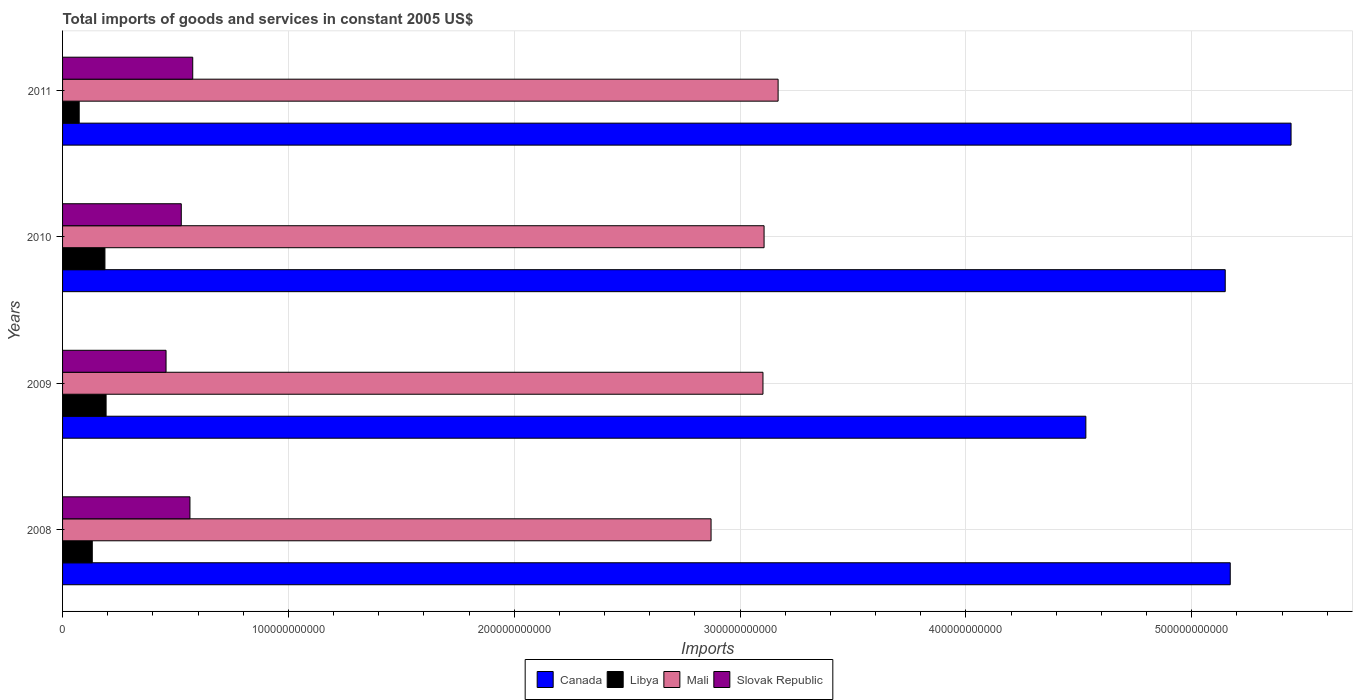Are the number of bars on each tick of the Y-axis equal?
Keep it short and to the point. Yes. How many bars are there on the 4th tick from the top?
Offer a very short reply. 4. What is the total imports of goods and services in Libya in 2010?
Provide a short and direct response. 1.88e+1. Across all years, what is the maximum total imports of goods and services in Slovak Republic?
Your answer should be compact. 5.76e+1. Across all years, what is the minimum total imports of goods and services in Canada?
Provide a short and direct response. 4.53e+11. In which year was the total imports of goods and services in Libya maximum?
Offer a very short reply. 2009. What is the total total imports of goods and services in Slovak Republic in the graph?
Provide a short and direct response. 2.12e+11. What is the difference between the total imports of goods and services in Slovak Republic in 2008 and that in 2009?
Offer a very short reply. 1.06e+1. What is the difference between the total imports of goods and services in Mali in 2009 and the total imports of goods and services in Slovak Republic in 2008?
Keep it short and to the point. 2.54e+11. What is the average total imports of goods and services in Mali per year?
Offer a very short reply. 3.06e+11. In the year 2011, what is the difference between the total imports of goods and services in Mali and total imports of goods and services in Slovak Republic?
Provide a short and direct response. 2.59e+11. In how many years, is the total imports of goods and services in Canada greater than 100000000000 US$?
Your answer should be compact. 4. What is the ratio of the total imports of goods and services in Slovak Republic in 2010 to that in 2011?
Give a very brief answer. 0.91. Is the total imports of goods and services in Mali in 2010 less than that in 2011?
Provide a succinct answer. Yes. What is the difference between the highest and the second highest total imports of goods and services in Canada?
Keep it short and to the point. 2.69e+1. What is the difference between the highest and the lowest total imports of goods and services in Libya?
Ensure brevity in your answer.  1.19e+1. In how many years, is the total imports of goods and services in Slovak Republic greater than the average total imports of goods and services in Slovak Republic taken over all years?
Offer a very short reply. 2. Is the sum of the total imports of goods and services in Libya in 2009 and 2010 greater than the maximum total imports of goods and services in Mali across all years?
Your answer should be compact. No. What does the 1st bar from the top in 2009 represents?
Provide a short and direct response. Slovak Republic. How many bars are there?
Give a very brief answer. 16. Are all the bars in the graph horizontal?
Offer a very short reply. Yes. How many years are there in the graph?
Keep it short and to the point. 4. What is the difference between two consecutive major ticks on the X-axis?
Your answer should be very brief. 1.00e+11. Are the values on the major ticks of X-axis written in scientific E-notation?
Your answer should be compact. No. How are the legend labels stacked?
Give a very brief answer. Horizontal. What is the title of the graph?
Ensure brevity in your answer.  Total imports of goods and services in constant 2005 US$. What is the label or title of the X-axis?
Your answer should be very brief. Imports. What is the label or title of the Y-axis?
Ensure brevity in your answer.  Years. What is the Imports in Canada in 2008?
Your answer should be compact. 5.17e+11. What is the Imports of Libya in 2008?
Offer a terse response. 1.32e+1. What is the Imports of Mali in 2008?
Your answer should be compact. 2.87e+11. What is the Imports of Slovak Republic in 2008?
Ensure brevity in your answer.  5.64e+1. What is the Imports of Canada in 2009?
Offer a very short reply. 4.53e+11. What is the Imports in Libya in 2009?
Your answer should be compact. 1.93e+1. What is the Imports of Mali in 2009?
Your answer should be very brief. 3.10e+11. What is the Imports of Slovak Republic in 2009?
Your response must be concise. 4.58e+1. What is the Imports of Canada in 2010?
Give a very brief answer. 5.15e+11. What is the Imports in Libya in 2010?
Your answer should be compact. 1.88e+1. What is the Imports of Mali in 2010?
Ensure brevity in your answer.  3.11e+11. What is the Imports of Slovak Republic in 2010?
Your answer should be very brief. 5.26e+1. What is the Imports in Canada in 2011?
Provide a succinct answer. 5.44e+11. What is the Imports of Libya in 2011?
Your answer should be very brief. 7.36e+09. What is the Imports in Mali in 2011?
Offer a terse response. 3.17e+11. What is the Imports in Slovak Republic in 2011?
Your response must be concise. 5.76e+1. Across all years, what is the maximum Imports in Canada?
Provide a short and direct response. 5.44e+11. Across all years, what is the maximum Imports in Libya?
Give a very brief answer. 1.93e+1. Across all years, what is the maximum Imports of Mali?
Give a very brief answer. 3.17e+11. Across all years, what is the maximum Imports in Slovak Republic?
Make the answer very short. 5.76e+1. Across all years, what is the minimum Imports of Canada?
Your response must be concise. 4.53e+11. Across all years, what is the minimum Imports in Libya?
Give a very brief answer. 7.36e+09. Across all years, what is the minimum Imports of Mali?
Keep it short and to the point. 2.87e+11. Across all years, what is the minimum Imports in Slovak Republic?
Your answer should be compact. 4.58e+1. What is the total Imports in Canada in the graph?
Make the answer very short. 2.03e+12. What is the total Imports of Libya in the graph?
Provide a succinct answer. 5.86e+1. What is the total Imports of Mali in the graph?
Offer a very short reply. 1.22e+12. What is the total Imports of Slovak Republic in the graph?
Your answer should be compact. 2.12e+11. What is the difference between the Imports in Canada in 2008 and that in 2009?
Provide a succinct answer. 6.39e+1. What is the difference between the Imports of Libya in 2008 and that in 2009?
Offer a very short reply. -6.12e+09. What is the difference between the Imports of Mali in 2008 and that in 2009?
Give a very brief answer. -2.30e+1. What is the difference between the Imports in Slovak Republic in 2008 and that in 2009?
Offer a terse response. 1.06e+1. What is the difference between the Imports of Canada in 2008 and that in 2010?
Make the answer very short. 2.22e+09. What is the difference between the Imports of Libya in 2008 and that in 2010?
Offer a very short reply. -5.60e+09. What is the difference between the Imports in Mali in 2008 and that in 2010?
Give a very brief answer. -2.35e+1. What is the difference between the Imports of Slovak Republic in 2008 and that in 2010?
Your answer should be compact. 3.84e+09. What is the difference between the Imports in Canada in 2008 and that in 2011?
Give a very brief answer. -2.69e+1. What is the difference between the Imports in Libya in 2008 and that in 2011?
Ensure brevity in your answer.  5.79e+09. What is the difference between the Imports of Mali in 2008 and that in 2011?
Give a very brief answer. -2.97e+1. What is the difference between the Imports of Slovak Republic in 2008 and that in 2011?
Offer a terse response. -1.23e+09. What is the difference between the Imports in Canada in 2009 and that in 2010?
Offer a very short reply. -6.17e+1. What is the difference between the Imports of Libya in 2009 and that in 2010?
Your answer should be very brief. 5.16e+08. What is the difference between the Imports in Mali in 2009 and that in 2010?
Your answer should be compact. -4.91e+08. What is the difference between the Imports of Slovak Republic in 2009 and that in 2010?
Provide a succinct answer. -6.74e+09. What is the difference between the Imports in Canada in 2009 and that in 2011?
Offer a very short reply. -9.09e+1. What is the difference between the Imports in Libya in 2009 and that in 2011?
Keep it short and to the point. 1.19e+1. What is the difference between the Imports of Mali in 2009 and that in 2011?
Provide a short and direct response. -6.70e+09. What is the difference between the Imports of Slovak Republic in 2009 and that in 2011?
Keep it short and to the point. -1.18e+1. What is the difference between the Imports of Canada in 2010 and that in 2011?
Offer a terse response. -2.91e+1. What is the difference between the Imports of Libya in 2010 and that in 2011?
Your answer should be very brief. 1.14e+1. What is the difference between the Imports in Mali in 2010 and that in 2011?
Keep it short and to the point. -6.21e+09. What is the difference between the Imports of Slovak Republic in 2010 and that in 2011?
Make the answer very short. -5.07e+09. What is the difference between the Imports in Canada in 2008 and the Imports in Libya in 2009?
Give a very brief answer. 4.98e+11. What is the difference between the Imports in Canada in 2008 and the Imports in Mali in 2009?
Make the answer very short. 2.07e+11. What is the difference between the Imports in Canada in 2008 and the Imports in Slovak Republic in 2009?
Your response must be concise. 4.71e+11. What is the difference between the Imports of Libya in 2008 and the Imports of Mali in 2009?
Your response must be concise. -2.97e+11. What is the difference between the Imports of Libya in 2008 and the Imports of Slovak Republic in 2009?
Offer a terse response. -3.27e+1. What is the difference between the Imports of Mali in 2008 and the Imports of Slovak Republic in 2009?
Your answer should be compact. 2.41e+11. What is the difference between the Imports of Canada in 2008 and the Imports of Libya in 2010?
Provide a short and direct response. 4.98e+11. What is the difference between the Imports in Canada in 2008 and the Imports in Mali in 2010?
Make the answer very short. 2.06e+11. What is the difference between the Imports of Canada in 2008 and the Imports of Slovak Republic in 2010?
Give a very brief answer. 4.64e+11. What is the difference between the Imports in Libya in 2008 and the Imports in Mali in 2010?
Ensure brevity in your answer.  -2.97e+11. What is the difference between the Imports of Libya in 2008 and the Imports of Slovak Republic in 2010?
Provide a short and direct response. -3.94e+1. What is the difference between the Imports in Mali in 2008 and the Imports in Slovak Republic in 2010?
Provide a succinct answer. 2.35e+11. What is the difference between the Imports of Canada in 2008 and the Imports of Libya in 2011?
Keep it short and to the point. 5.10e+11. What is the difference between the Imports in Canada in 2008 and the Imports in Mali in 2011?
Ensure brevity in your answer.  2.00e+11. What is the difference between the Imports of Canada in 2008 and the Imports of Slovak Republic in 2011?
Your answer should be compact. 4.59e+11. What is the difference between the Imports of Libya in 2008 and the Imports of Mali in 2011?
Offer a very short reply. -3.04e+11. What is the difference between the Imports in Libya in 2008 and the Imports in Slovak Republic in 2011?
Your response must be concise. -4.45e+1. What is the difference between the Imports in Mali in 2008 and the Imports in Slovak Republic in 2011?
Provide a succinct answer. 2.30e+11. What is the difference between the Imports in Canada in 2009 and the Imports in Libya in 2010?
Provide a short and direct response. 4.34e+11. What is the difference between the Imports of Canada in 2009 and the Imports of Mali in 2010?
Your answer should be compact. 1.42e+11. What is the difference between the Imports in Canada in 2009 and the Imports in Slovak Republic in 2010?
Keep it short and to the point. 4.01e+11. What is the difference between the Imports in Libya in 2009 and the Imports in Mali in 2010?
Provide a short and direct response. -2.91e+11. What is the difference between the Imports of Libya in 2009 and the Imports of Slovak Republic in 2010?
Offer a very short reply. -3.33e+1. What is the difference between the Imports of Mali in 2009 and the Imports of Slovak Republic in 2010?
Offer a very short reply. 2.58e+11. What is the difference between the Imports of Canada in 2009 and the Imports of Libya in 2011?
Provide a short and direct response. 4.46e+11. What is the difference between the Imports in Canada in 2009 and the Imports in Mali in 2011?
Offer a very short reply. 1.36e+11. What is the difference between the Imports in Canada in 2009 and the Imports in Slovak Republic in 2011?
Offer a terse response. 3.95e+11. What is the difference between the Imports of Libya in 2009 and the Imports of Mali in 2011?
Provide a short and direct response. -2.98e+11. What is the difference between the Imports of Libya in 2009 and the Imports of Slovak Republic in 2011?
Your response must be concise. -3.84e+1. What is the difference between the Imports of Mali in 2009 and the Imports of Slovak Republic in 2011?
Make the answer very short. 2.52e+11. What is the difference between the Imports in Canada in 2010 and the Imports in Libya in 2011?
Your answer should be very brief. 5.07e+11. What is the difference between the Imports in Canada in 2010 and the Imports in Mali in 2011?
Provide a succinct answer. 1.98e+11. What is the difference between the Imports of Canada in 2010 and the Imports of Slovak Republic in 2011?
Ensure brevity in your answer.  4.57e+11. What is the difference between the Imports in Libya in 2010 and the Imports in Mali in 2011?
Your answer should be very brief. -2.98e+11. What is the difference between the Imports in Libya in 2010 and the Imports in Slovak Republic in 2011?
Provide a succinct answer. -3.89e+1. What is the difference between the Imports in Mali in 2010 and the Imports in Slovak Republic in 2011?
Give a very brief answer. 2.53e+11. What is the average Imports in Canada per year?
Give a very brief answer. 5.07e+11. What is the average Imports in Libya per year?
Keep it short and to the point. 1.46e+1. What is the average Imports of Mali per year?
Your response must be concise. 3.06e+11. What is the average Imports in Slovak Republic per year?
Your answer should be compact. 5.31e+1. In the year 2008, what is the difference between the Imports in Canada and Imports in Libya?
Ensure brevity in your answer.  5.04e+11. In the year 2008, what is the difference between the Imports of Canada and Imports of Mali?
Your answer should be very brief. 2.30e+11. In the year 2008, what is the difference between the Imports in Canada and Imports in Slovak Republic?
Your answer should be compact. 4.61e+11. In the year 2008, what is the difference between the Imports of Libya and Imports of Mali?
Keep it short and to the point. -2.74e+11. In the year 2008, what is the difference between the Imports of Libya and Imports of Slovak Republic?
Offer a terse response. -4.33e+1. In the year 2008, what is the difference between the Imports in Mali and Imports in Slovak Republic?
Provide a succinct answer. 2.31e+11. In the year 2009, what is the difference between the Imports in Canada and Imports in Libya?
Make the answer very short. 4.34e+11. In the year 2009, what is the difference between the Imports of Canada and Imports of Mali?
Offer a terse response. 1.43e+11. In the year 2009, what is the difference between the Imports in Canada and Imports in Slovak Republic?
Offer a terse response. 4.07e+11. In the year 2009, what is the difference between the Imports of Libya and Imports of Mali?
Your answer should be very brief. -2.91e+11. In the year 2009, what is the difference between the Imports in Libya and Imports in Slovak Republic?
Your answer should be very brief. -2.65e+1. In the year 2009, what is the difference between the Imports of Mali and Imports of Slovak Republic?
Make the answer very short. 2.64e+11. In the year 2010, what is the difference between the Imports in Canada and Imports in Libya?
Provide a succinct answer. 4.96e+11. In the year 2010, what is the difference between the Imports of Canada and Imports of Mali?
Your answer should be compact. 2.04e+11. In the year 2010, what is the difference between the Imports in Canada and Imports in Slovak Republic?
Ensure brevity in your answer.  4.62e+11. In the year 2010, what is the difference between the Imports in Libya and Imports in Mali?
Your response must be concise. -2.92e+11. In the year 2010, what is the difference between the Imports of Libya and Imports of Slovak Republic?
Offer a terse response. -3.38e+1. In the year 2010, what is the difference between the Imports in Mali and Imports in Slovak Republic?
Make the answer very short. 2.58e+11. In the year 2011, what is the difference between the Imports of Canada and Imports of Libya?
Your response must be concise. 5.37e+11. In the year 2011, what is the difference between the Imports of Canada and Imports of Mali?
Offer a very short reply. 2.27e+11. In the year 2011, what is the difference between the Imports of Canada and Imports of Slovak Republic?
Offer a terse response. 4.86e+11. In the year 2011, what is the difference between the Imports in Libya and Imports in Mali?
Your response must be concise. -3.09e+11. In the year 2011, what is the difference between the Imports of Libya and Imports of Slovak Republic?
Provide a short and direct response. -5.03e+1. In the year 2011, what is the difference between the Imports in Mali and Imports in Slovak Republic?
Offer a very short reply. 2.59e+11. What is the ratio of the Imports in Canada in 2008 to that in 2009?
Ensure brevity in your answer.  1.14. What is the ratio of the Imports in Libya in 2008 to that in 2009?
Offer a terse response. 0.68. What is the ratio of the Imports of Mali in 2008 to that in 2009?
Give a very brief answer. 0.93. What is the ratio of the Imports in Slovak Republic in 2008 to that in 2009?
Your response must be concise. 1.23. What is the ratio of the Imports of Libya in 2008 to that in 2010?
Provide a short and direct response. 0.7. What is the ratio of the Imports in Mali in 2008 to that in 2010?
Your answer should be very brief. 0.92. What is the ratio of the Imports of Slovak Republic in 2008 to that in 2010?
Provide a short and direct response. 1.07. What is the ratio of the Imports of Canada in 2008 to that in 2011?
Offer a terse response. 0.95. What is the ratio of the Imports of Libya in 2008 to that in 2011?
Keep it short and to the point. 1.79. What is the ratio of the Imports in Mali in 2008 to that in 2011?
Offer a very short reply. 0.91. What is the ratio of the Imports of Slovak Republic in 2008 to that in 2011?
Ensure brevity in your answer.  0.98. What is the ratio of the Imports of Canada in 2009 to that in 2010?
Your answer should be compact. 0.88. What is the ratio of the Imports of Libya in 2009 to that in 2010?
Ensure brevity in your answer.  1.03. What is the ratio of the Imports of Mali in 2009 to that in 2010?
Your answer should be very brief. 1. What is the ratio of the Imports in Slovak Republic in 2009 to that in 2010?
Provide a short and direct response. 0.87. What is the ratio of the Imports in Canada in 2009 to that in 2011?
Ensure brevity in your answer.  0.83. What is the ratio of the Imports in Libya in 2009 to that in 2011?
Offer a terse response. 2.62. What is the ratio of the Imports of Mali in 2009 to that in 2011?
Ensure brevity in your answer.  0.98. What is the ratio of the Imports in Slovak Republic in 2009 to that in 2011?
Your answer should be compact. 0.8. What is the ratio of the Imports in Canada in 2010 to that in 2011?
Keep it short and to the point. 0.95. What is the ratio of the Imports in Libya in 2010 to that in 2011?
Provide a short and direct response. 2.55. What is the ratio of the Imports in Mali in 2010 to that in 2011?
Provide a succinct answer. 0.98. What is the ratio of the Imports in Slovak Republic in 2010 to that in 2011?
Ensure brevity in your answer.  0.91. What is the difference between the highest and the second highest Imports in Canada?
Your answer should be compact. 2.69e+1. What is the difference between the highest and the second highest Imports of Libya?
Your response must be concise. 5.16e+08. What is the difference between the highest and the second highest Imports in Mali?
Make the answer very short. 6.21e+09. What is the difference between the highest and the second highest Imports of Slovak Republic?
Your answer should be very brief. 1.23e+09. What is the difference between the highest and the lowest Imports in Canada?
Your response must be concise. 9.09e+1. What is the difference between the highest and the lowest Imports of Libya?
Ensure brevity in your answer.  1.19e+1. What is the difference between the highest and the lowest Imports of Mali?
Provide a short and direct response. 2.97e+1. What is the difference between the highest and the lowest Imports of Slovak Republic?
Ensure brevity in your answer.  1.18e+1. 